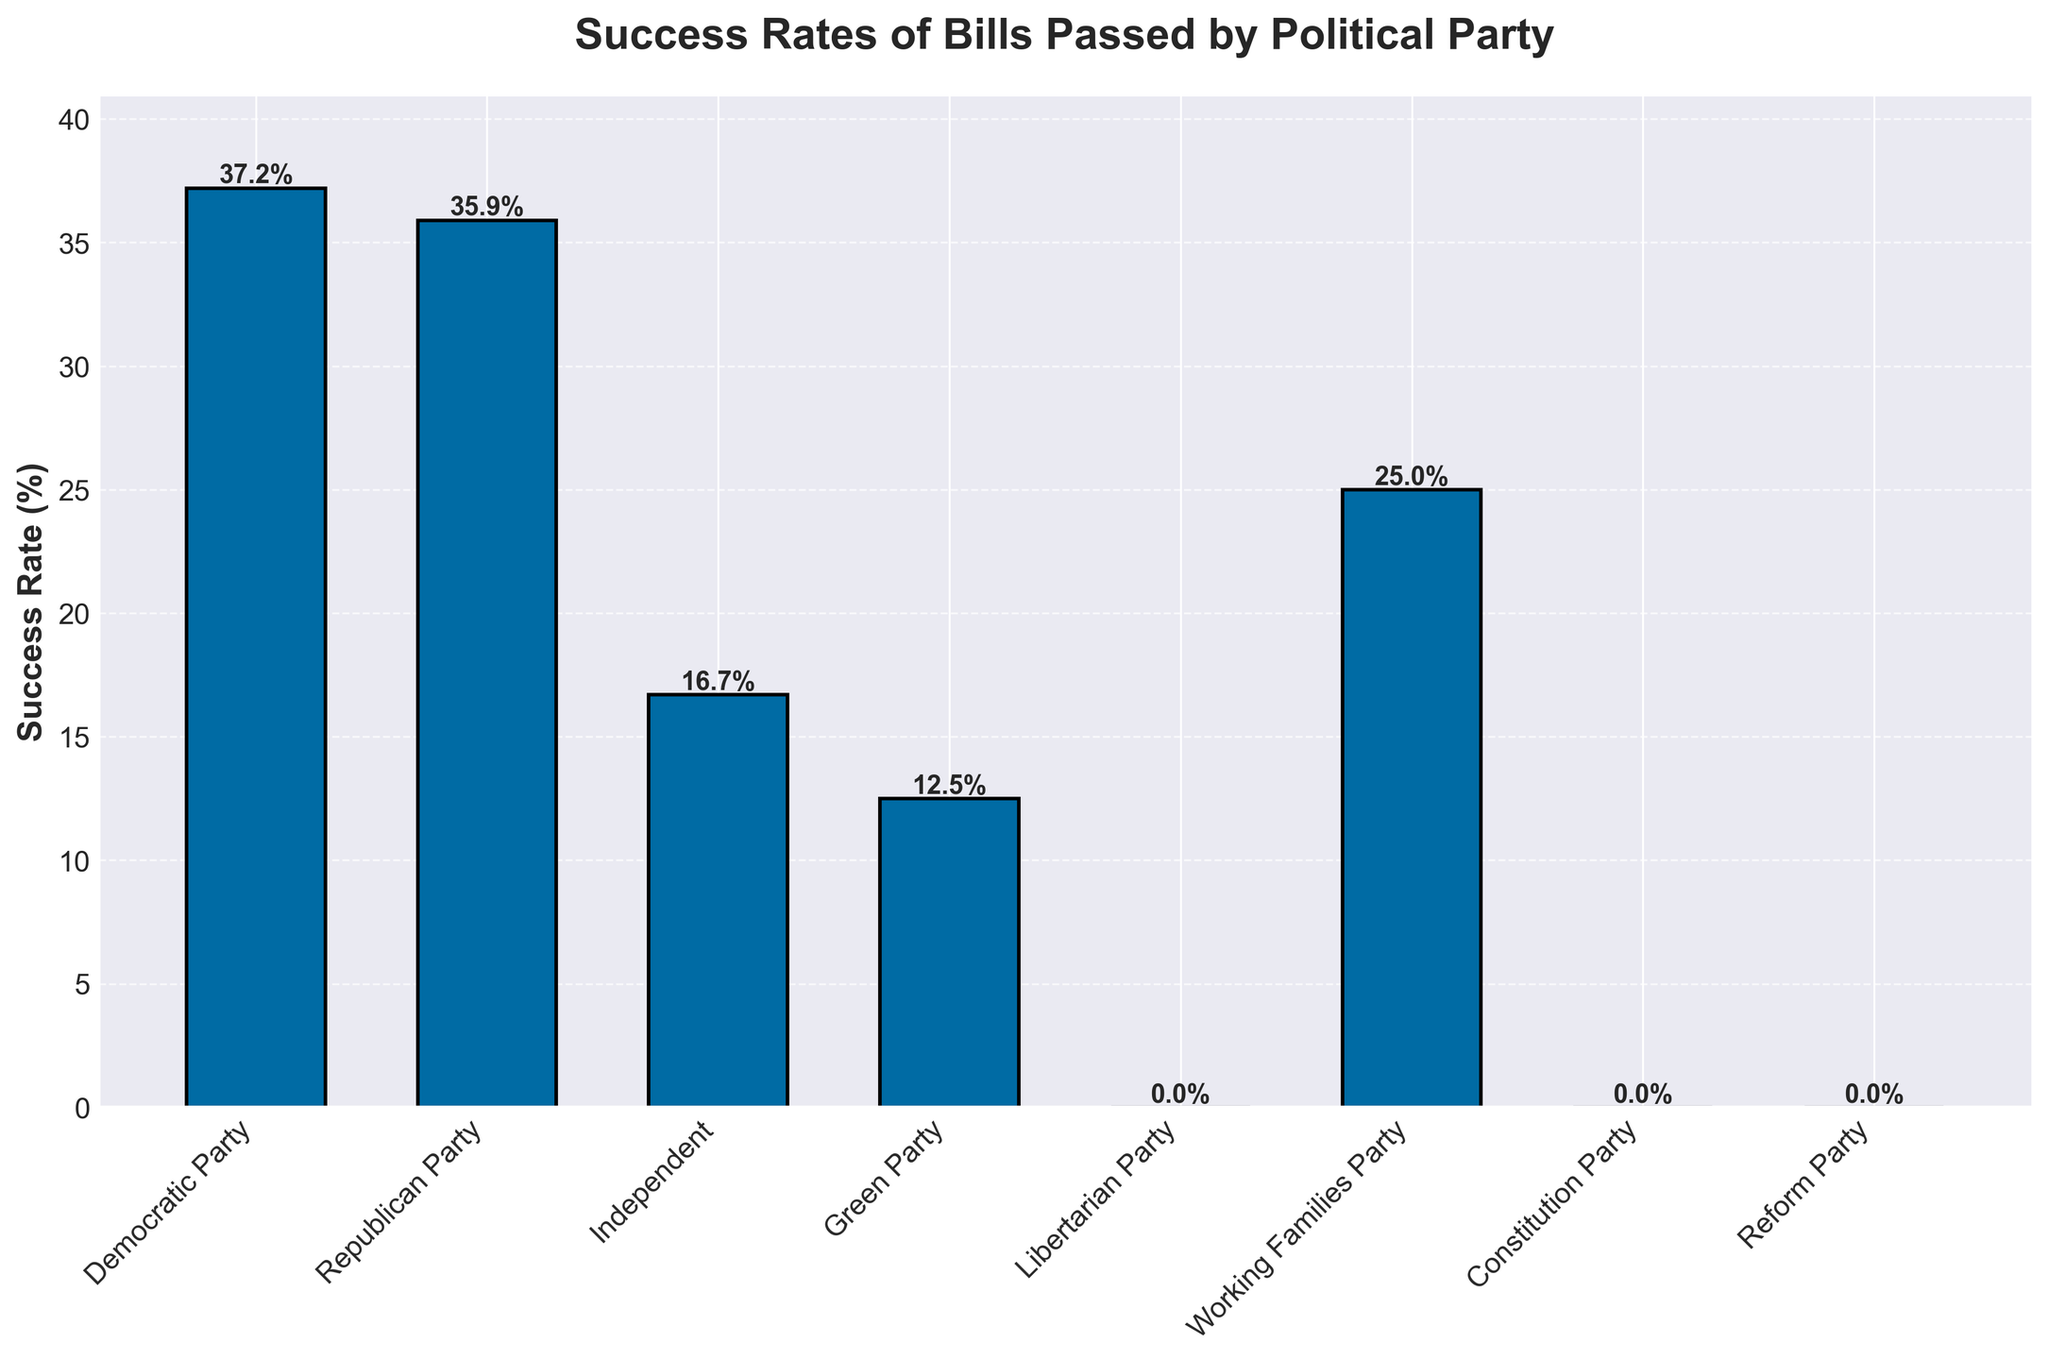What's the success rate of bills passed by the Democratic Party? The bar corresponding to the Democratic Party shows a success rate, which can be read directly from the label on the figure.
Answer: 37.2% Which party has the lowest success rate of bills passed? The party with the lowest bar represents the lowest success rate. From the plot, the Libertarian Party, Constitution Party, and Reform Party all have a success rate of 0%.
Answer: Libertarian Party, Constitution Party, and Reform Party How does the success rate of the Independent party compare to the Green Party? Compare the heights of the bars corresponding to the Independent and Green Parties. The Independent Party has a higher success rate than the Green Party.
Answer: Independent Party has a higher success rate Which parties have a success rate of more than 30%? Identify the bars exceeding the 30% mark on the y-axis. Both the Democratic Party and Republican Party have success rates above 30%.
Answer: Democratic Party and Republican Party What's the difference in success rates between the party with the highest and the party with the lowest success rate? The Democratic Party has the highest success rate at 37.2%, and the Libertarian Party, Constitution Party, and Reform Party have the lowest at 0%. The difference is 37.2% - 0%.
Answer: 37.2% Rank the parties from highest to lowest success rate. Look at the heights of the bars and their associated rates and list them in descending order: Democratic Party, Republican Party, Working Families Party, Independent, Green Party, Libertarian Party, Constitution Party, Reform Party.
Answer: Democratic Party, Republican Party, Working Families Party, Independent, Green Party, Libertarian Party, Constitution Party, Reform Party What is the average success rate of all the parties combined? First, sum the percentages of all parties: 37.2 + 35.9 + 16.7 + 12.5 + 0 + 25 + 0 + 0 = 127.3%. Next, divide by the number of parties, which is 8: 127.3 / 8 ≈ 15.91%.
Answer: 15.91% How many parties have a success rate of exactly 0%? Count the number of bars with a height corresponding to 0% success rate. The parties are Libertarian, Constitution, and Reform, so there are 3 parties.
Answer: 3 parties 